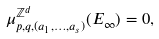<formula> <loc_0><loc_0><loc_500><loc_500>\mu ^ { \mathbb { Z } ^ { d } } _ { p , q , ( a _ { 1 } , \dots , a _ { s } ) } ( E _ { \infty } ) = 0 ,</formula> 